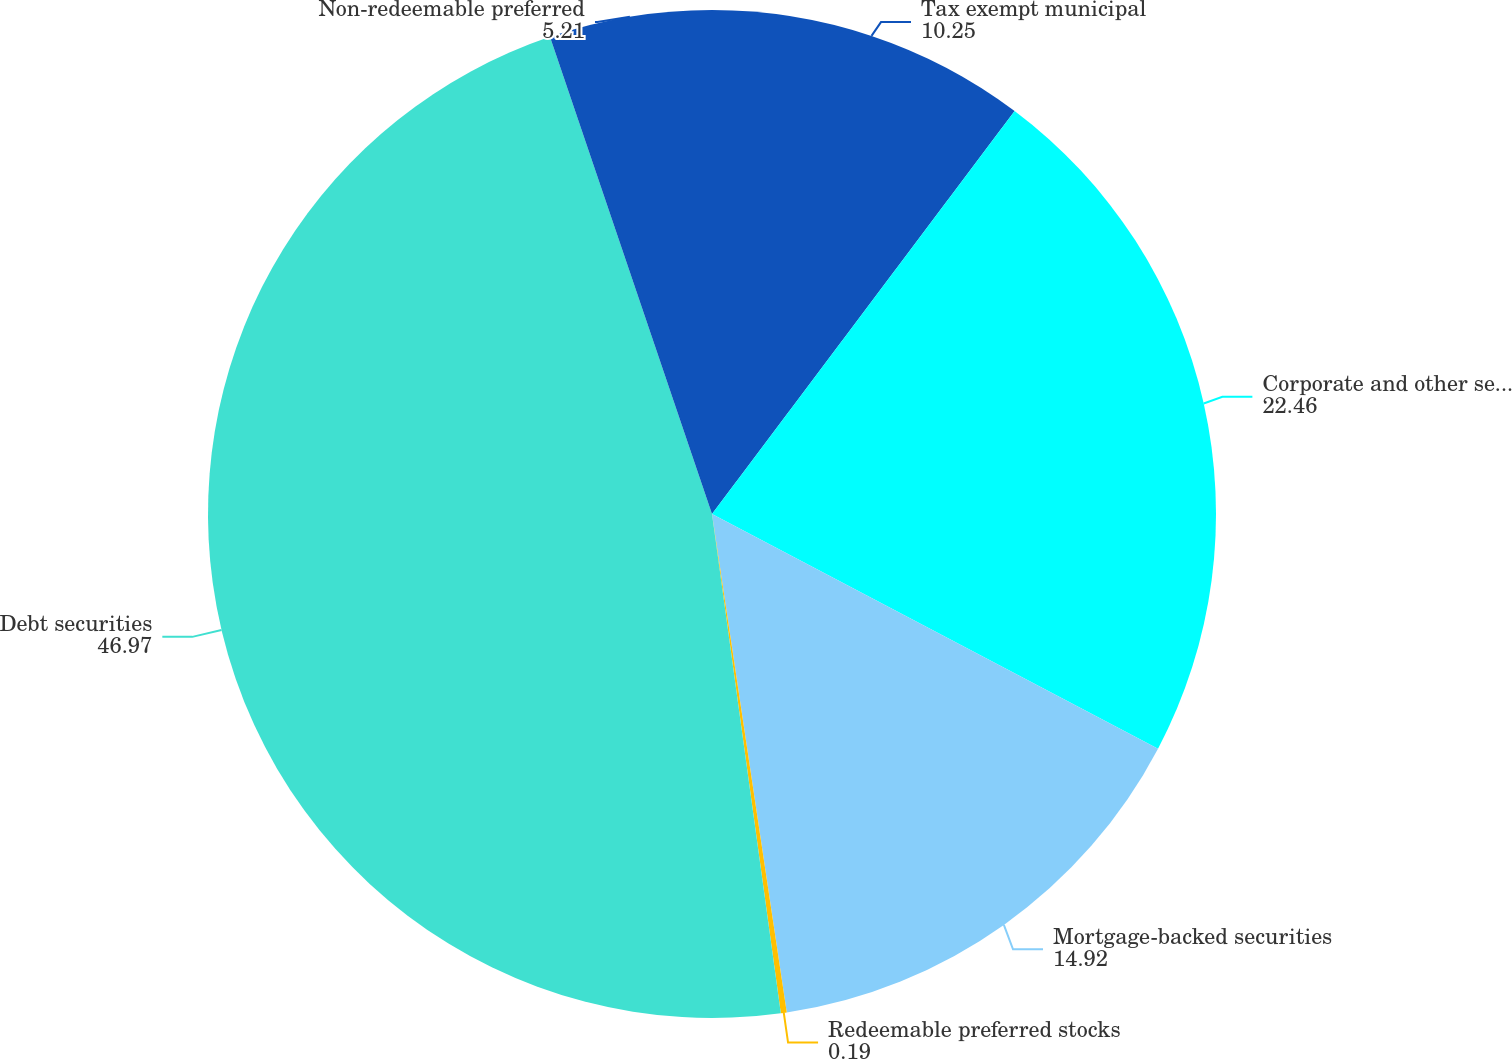<chart> <loc_0><loc_0><loc_500><loc_500><pie_chart><fcel>Tax exempt municipal<fcel>Corporate and other securities<fcel>Mortgage-backed securities<fcel>Redeemable preferred stocks<fcel>Debt securities<fcel>Non-redeemable preferred<nl><fcel>10.25%<fcel>22.46%<fcel>14.92%<fcel>0.19%<fcel>46.97%<fcel>5.21%<nl></chart> 